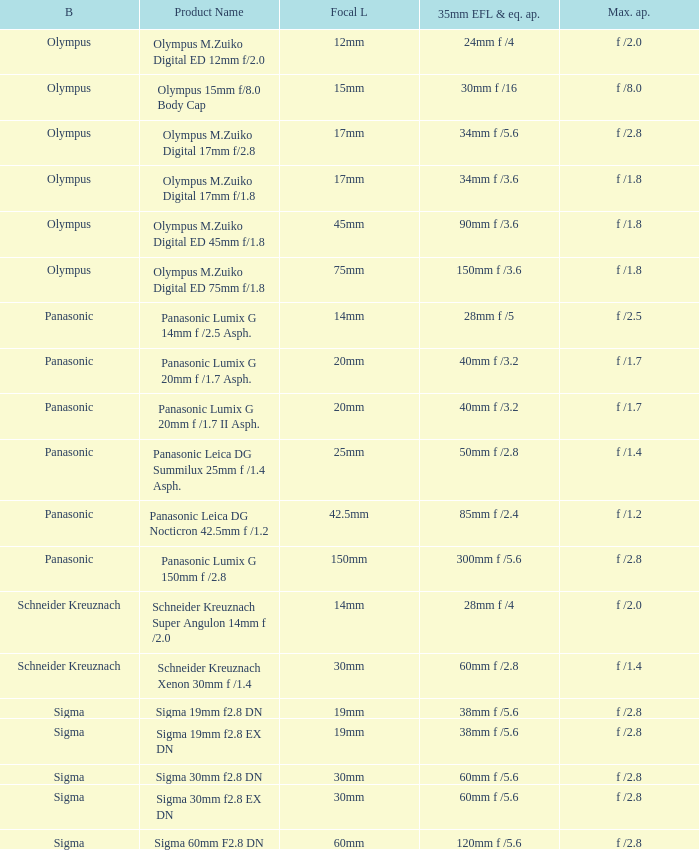What is the maximum aperture of the lens(es) with a focal length of 20mm? F /1.7, f /1.7. 